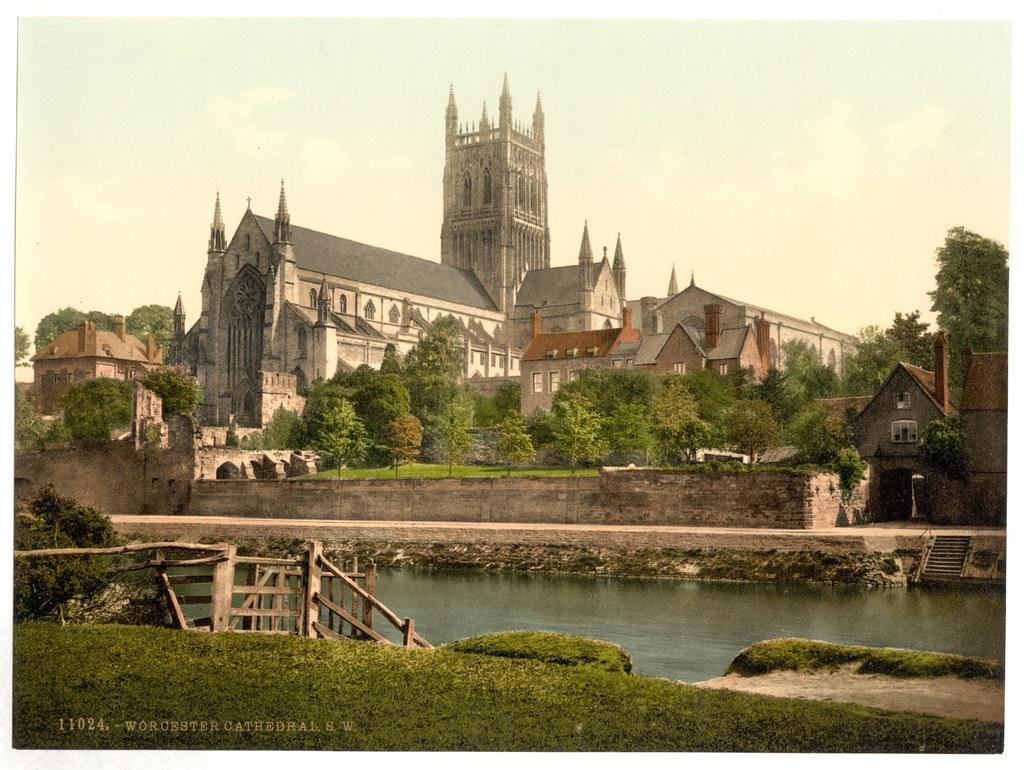How would you summarize this image in a sentence or two? In this picture I can observe a lake in the bottom of the picture. On the left side I can observe wooden railing. In the middle of the picture I can observe a building. There are some trees in this picture. In the background I can observe sky. 